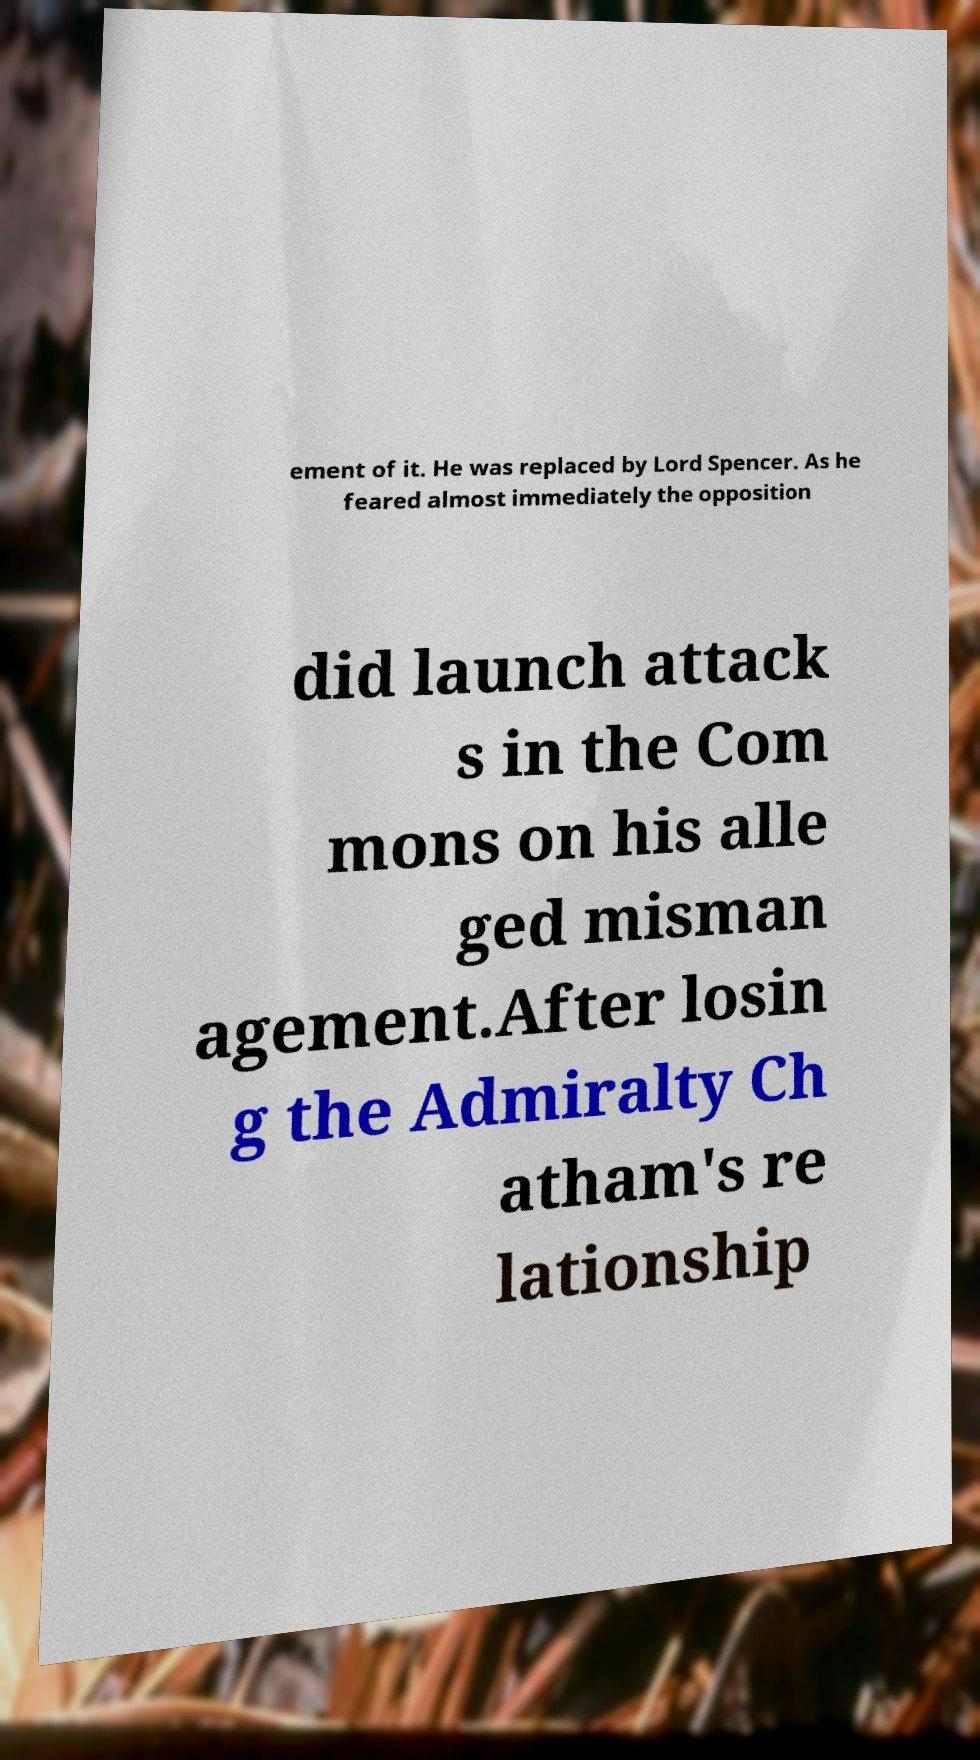Can you accurately transcribe the text from the provided image for me? ement of it. He was replaced by Lord Spencer. As he feared almost immediately the opposition did launch attack s in the Com mons on his alle ged misman agement.After losin g the Admiralty Ch atham's re lationship 